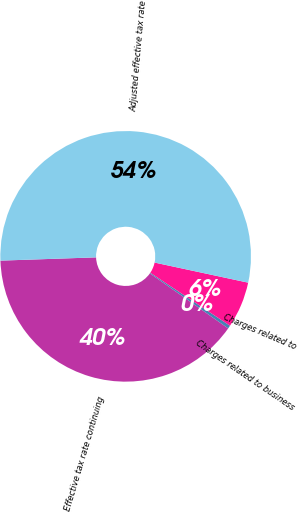Convert chart. <chart><loc_0><loc_0><loc_500><loc_500><pie_chart><fcel>Effective tax rate continuing<fcel>Charges related to business<fcel>Charges related to<fcel>Adjusted effective tax rate<nl><fcel>39.71%<fcel>0.41%<fcel>5.97%<fcel>53.91%<nl></chart> 